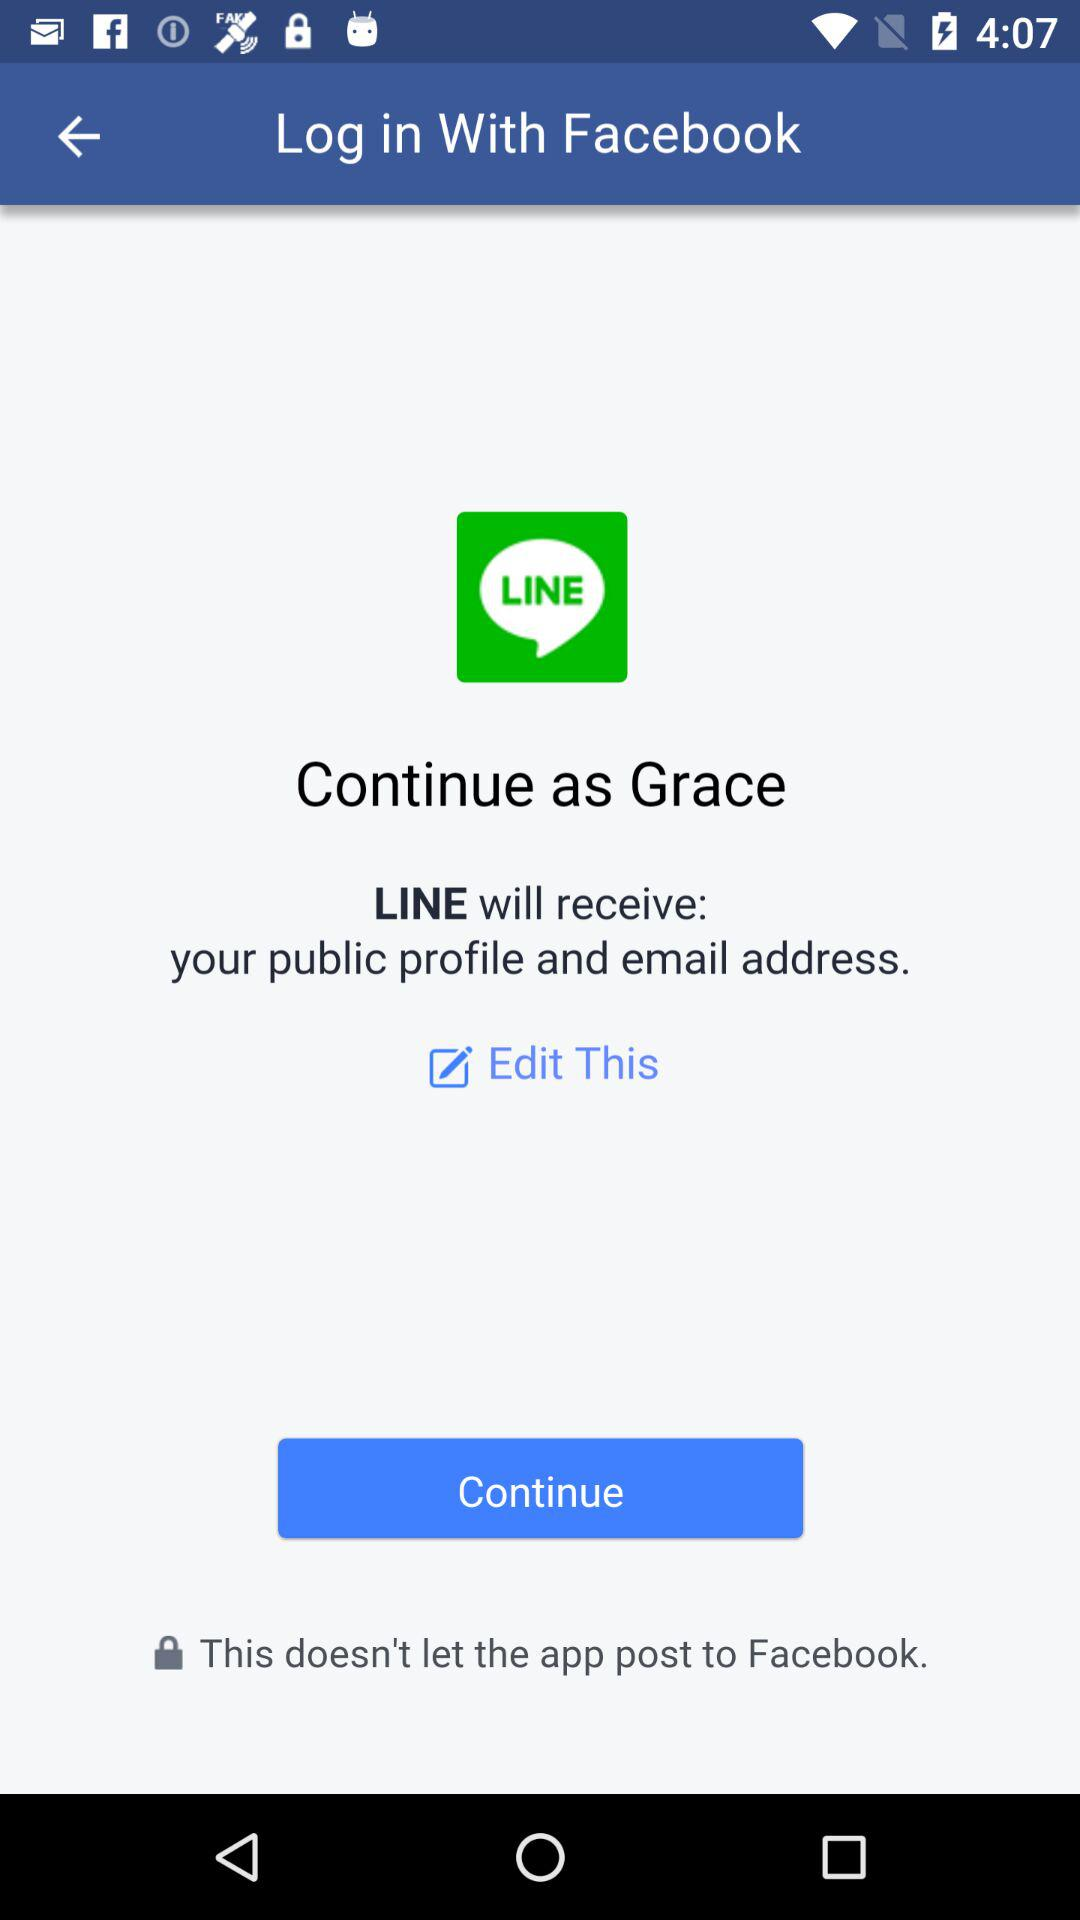What application is asking for permission? The application asking for permission is "LINE". 